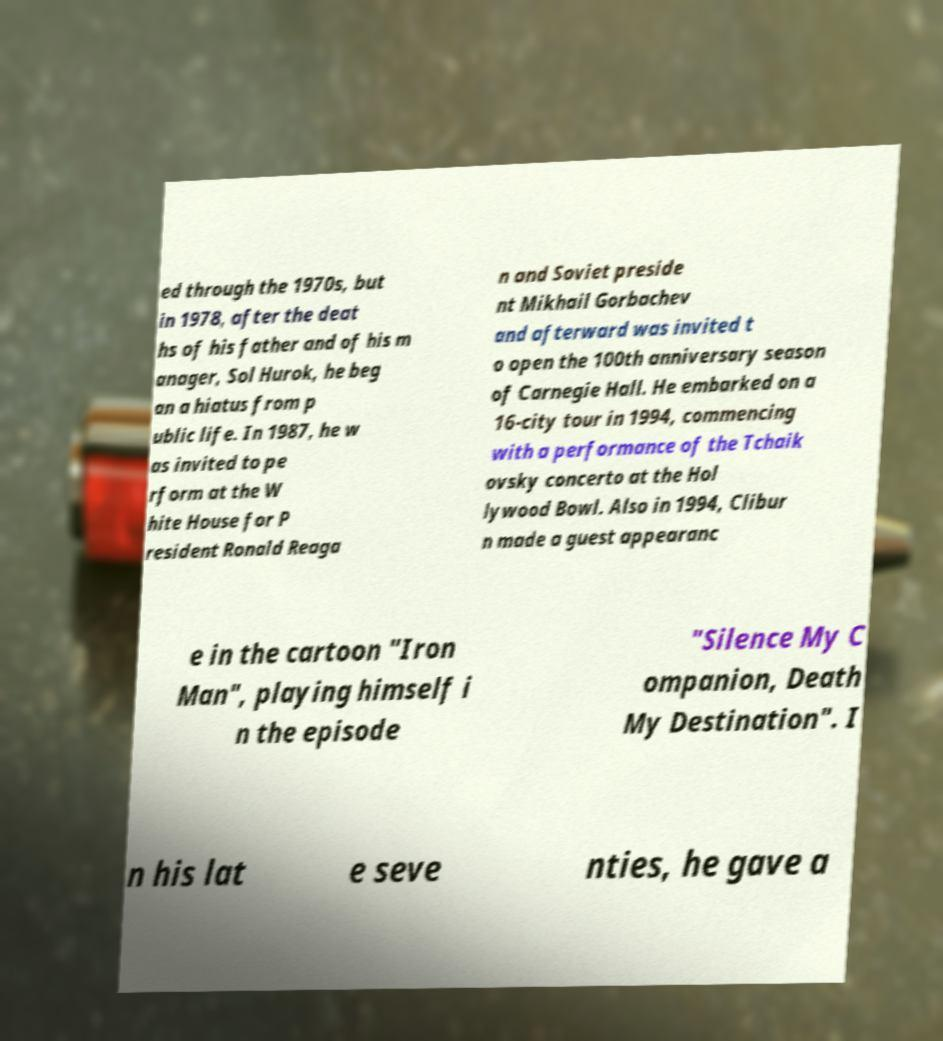Please read and relay the text visible in this image. What does it say? ed through the 1970s, but in 1978, after the deat hs of his father and of his m anager, Sol Hurok, he beg an a hiatus from p ublic life. In 1987, he w as invited to pe rform at the W hite House for P resident Ronald Reaga n and Soviet preside nt Mikhail Gorbachev and afterward was invited t o open the 100th anniversary season of Carnegie Hall. He embarked on a 16-city tour in 1994, commencing with a performance of the Tchaik ovsky concerto at the Hol lywood Bowl. Also in 1994, Clibur n made a guest appearanc e in the cartoon "Iron Man", playing himself i n the episode "Silence My C ompanion, Death My Destination". I n his lat e seve nties, he gave a 